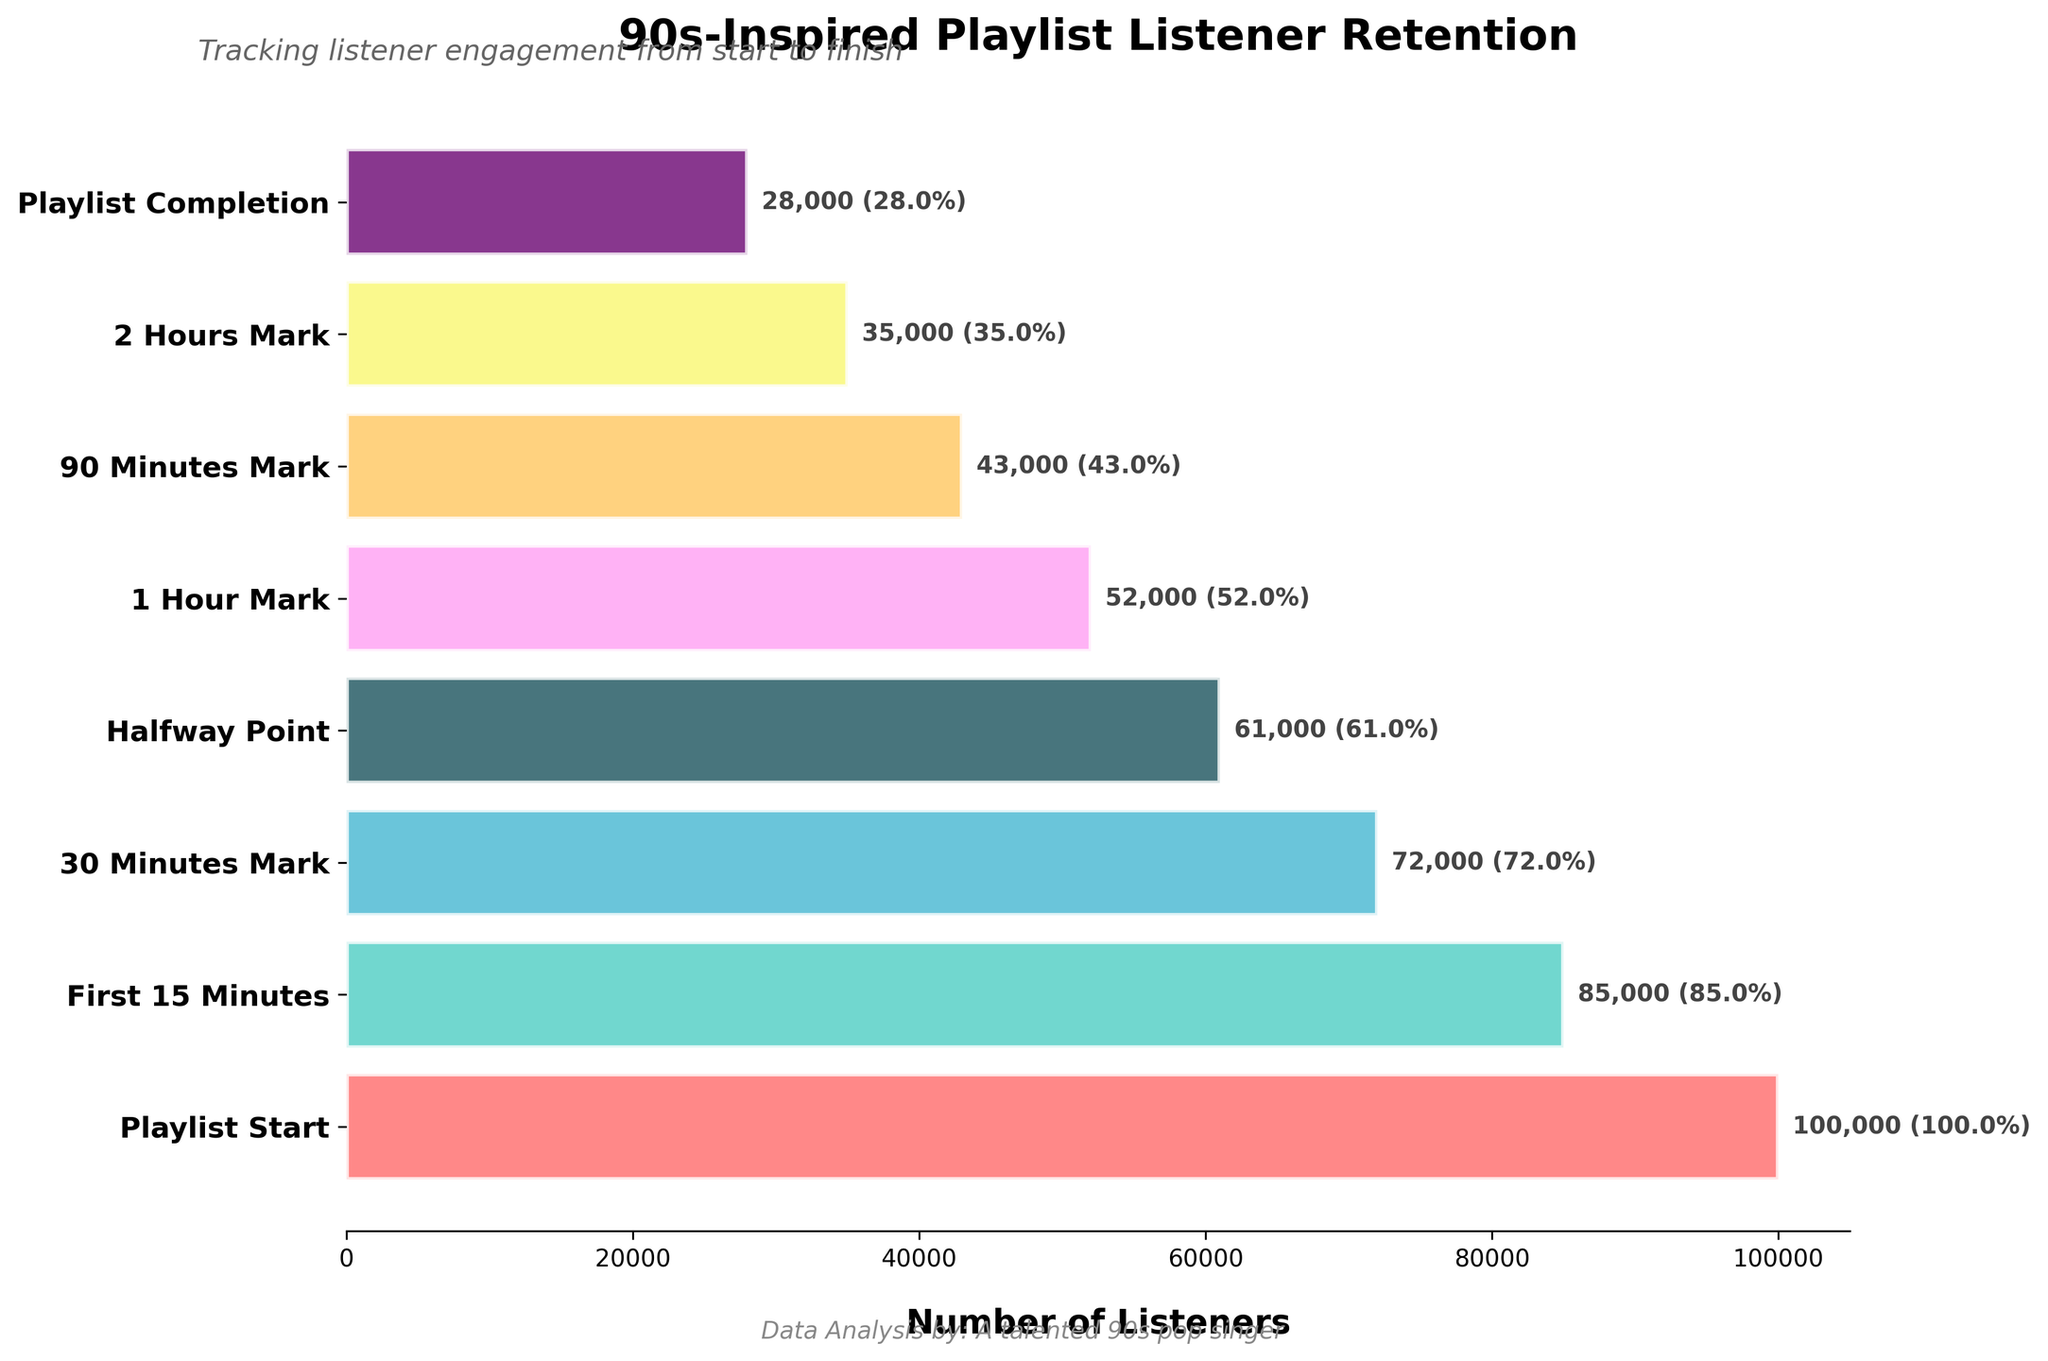What's the title of the plot? The title of the plot is located at the top of the figure. It is centered and in bold.
Answer: 90s-Inspired Playlist Listener Retention What stage has the highest retention rate? The retention rate is highest at the very beginning of the playlist. The stage with the highest number of listeners is the first stage.
Answer: Playlist Start How many listeners are lost between the 30 Minutes Mark and the Halfway Point? To find this number, subtract the number of listeners at the Halfway Point from the number of listeners at the 30 Minutes Mark. 72000 - 61000 = 11000
Answer: 11000 Which color represents the Playlist Completion stage? The specific color for each stage can be identified in the plot by looking at the color of the bar corresponding to the Playlist Completion stage.
Answer: Purple (assuming assigned colors in the list provided match) What percentage of listeners remain at the 1 Hour Mark? The number of listeners at the 1 Hour Mark is 52000. To find the percentage, divide this number by the initial number of listeners (100000) and multiply by 100. (52000 / 100000) * 100 = 52%
Answer: 52% How many listeners drop off between the First 15 Minutes and the 2 Hours Mark? Subtract the number of listeners at the 2 Hours Mark from those at the First 15 Minutes. 85000 - 35000 = 50000
Answer: 50000 Which stages have fewer than half of the original listeners? Calculate 50% of the initial number of listeners, which is 100000 * 0.5 = 50000. Stages with fewer listeners than this number are considered.
Answer: 1 Hour Mark, 90 Minutes Mark, 2 Hours Mark, Playlist Completion What is the average number of listeners across all stages? Sum the number of listeners across all stages and divide by the number of stages. (100000 + 85000 + 72000 + 61000 + 52000 + 43000 + 35000 + 28000) / 8 = 59125
Answer: 59125 What trend do you observe as the playlist progresses? Observing the bar lengths from start to end, there is a consistent decrease in the number of listeners, indicating a decline in listener retention as time progresses.
Answer: Consistent decrease What is the difference in listener count between the First 15 Minutes and Playlist Completion stages? Subtract the number of listeners at Playlist Completion from those at the First 15 Minutes. 85000 - 28000 = 57000
Answer: 57000 